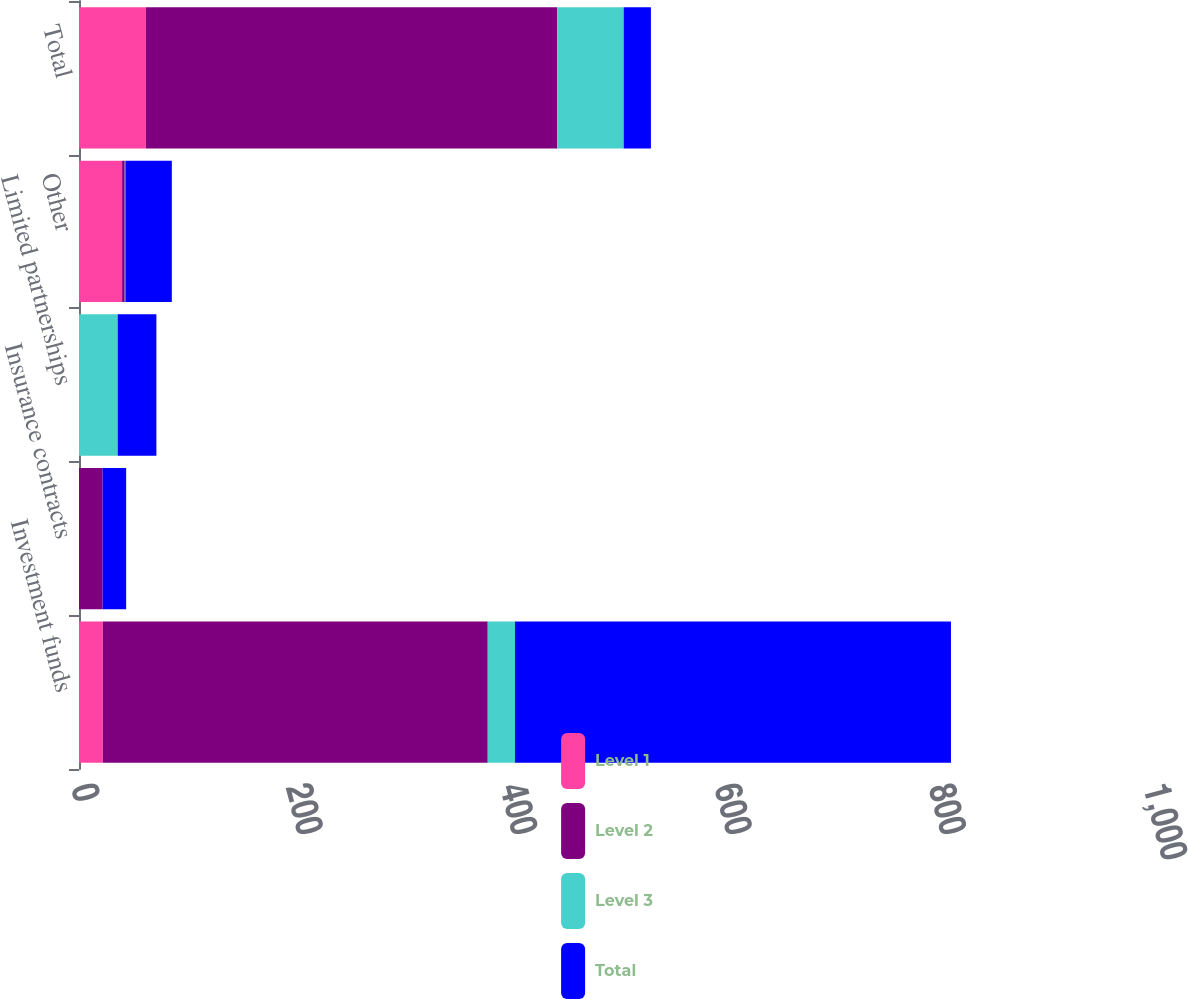<chart> <loc_0><loc_0><loc_500><loc_500><stacked_bar_chart><ecel><fcel>Investment funds<fcel>Insurance contracts<fcel>Limited partnerships<fcel>Other<fcel>Total<nl><fcel>Level 1<fcel>22.2<fcel>0<fcel>0<fcel>40.2<fcel>62.4<nl><fcel>Level 2<fcel>359.1<fcel>22<fcel>0<fcel>2.5<fcel>383.6<nl><fcel>Level 3<fcel>25.4<fcel>0<fcel>36.1<fcel>0.6<fcel>62.1<nl><fcel>Total<fcel>406.7<fcel>22<fcel>36.1<fcel>43.3<fcel>25.4<nl></chart> 